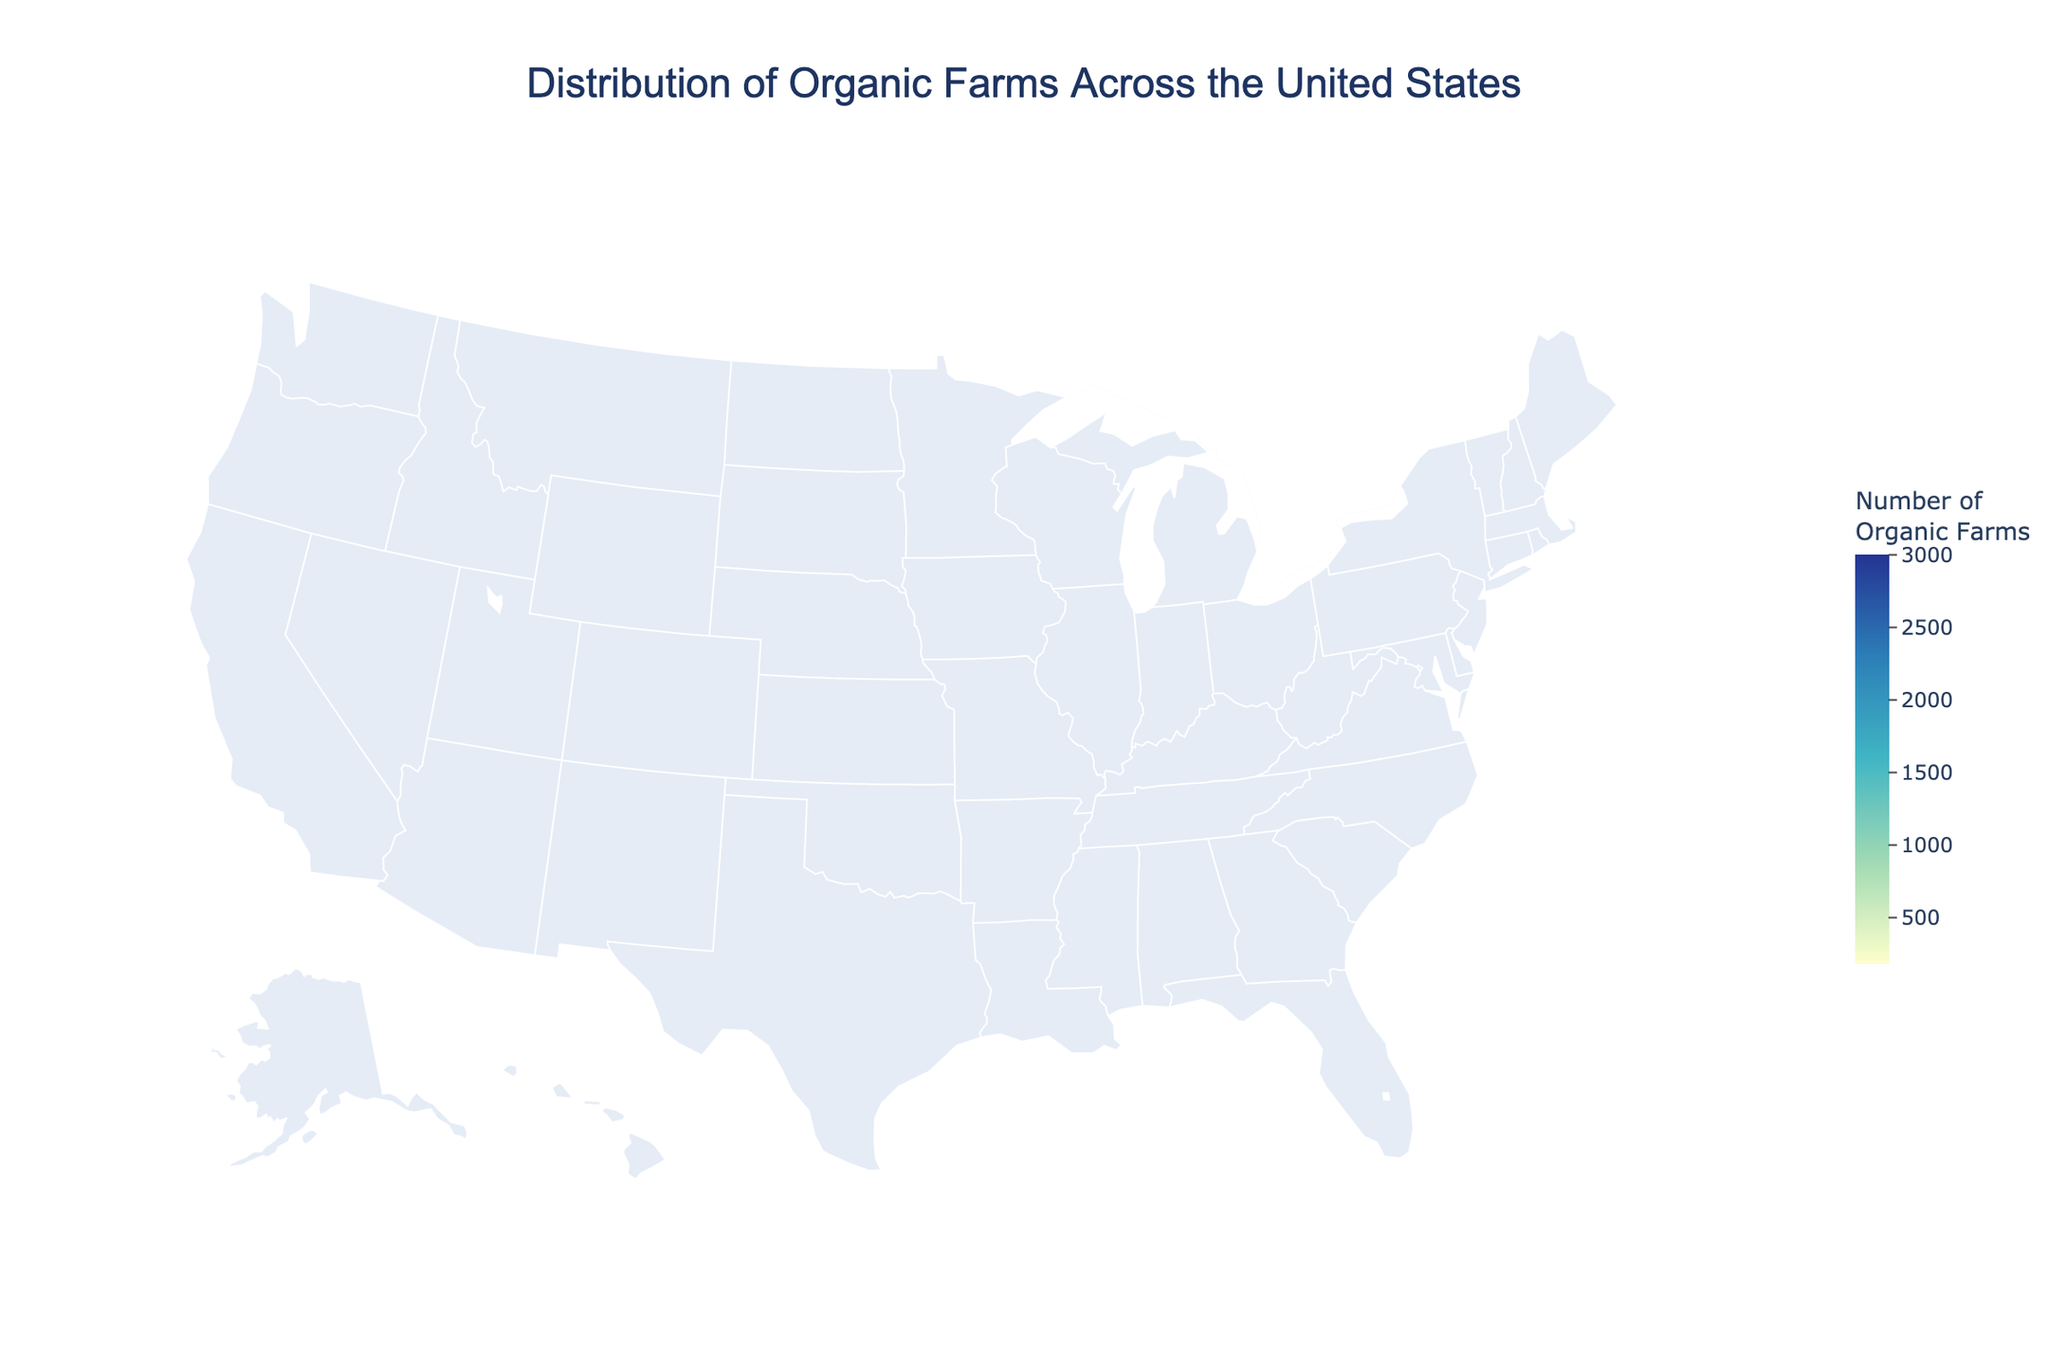What's the title of the figure? The title of the figure is usually displayed at the top-center of the plot, which helps in understanding the main focus of the visualization. Here, it reads "Distribution of Organic Farms Across the United States".
Answer: Distribution of Organic Farms Across the United States Which state has the highest number of organic farms? To identify the state with the highest number of organic farms, you look for the state with the darkest color, which indicates the highest value. According to the plot, California has the darkest shade, representing the highest number of organic farms.
Answer: California How many organic farms are in Ohio? To find the number of organic farms in Ohio, hover over Ohio on the map or check the annotations. The figure should indicate that Ohio has 400 organic farms.
Answer: 400 Which states have a "High" concentration level of organic farms? States with a "High" concentration level can be identified by checking the hover data or annotations. According to the source data, Wisconsin, New York, and Washington are listed with a "High" concentration level.
Answer: Wisconsin, New York, Washington What is the total number of organic farms in states with "Medium" concentration levels? To calculate the total number of organic farms in states with "Medium" concentration levels, sum the farms in states with that concentration level: Vermont (800), Oregon (750), Pennsylvania (700), and Maine (500). Thus, 800 + 750 + 700 + 500 = 2750.
Answer: 2750 Which state has a lower number of organic farms, Florida or Colorado? By comparing the annotations or hover data for Florida and Colorado, you can see Florida has 200 organic farms and Colorado has 180. Therefore, Colorado has fewer organic farms than Florida.
Answer: Colorado What is the concentration level of organic farms in Michigan? Hover over Michigan on the plot or check the annotations. The concentration level information will indicate that Michigan has a "Low" concentration level of organic farms.
Answer: Low How does the number of organic farms in Texas compare to that in New York? By examining the plot, the number of organic farms in Texas is 350, whereas New York has 1200 farms. Thus, New York has significantly more organic farms than Texas.
Answer: New York has more What’s the average number of organic farms among the states listed? To find the average number of organic farms, sum the number of farms in all listed states and divide by the number of states. Sum = 3000 + 1500 + 1200 + 1100 + 800 + 750 + 700 + 500 + 450 + 400 + 350 + 300 + 250 + 200 + 180 = 11680. Number of states = 15. Average = 11680 / 15 ≈ 779.
Answer: 779 Which regions of the United States are highlighted as having the highest concentration of organic farms? The regions with the highest concentration of organic farms are indicated by the darkest shades on the map. From the data, California, Wisconsin, New York, and Washington are the highlighted regions with "Very High" or "High" concentrations.
Answer: California, Wisconsin, New York, Washington 